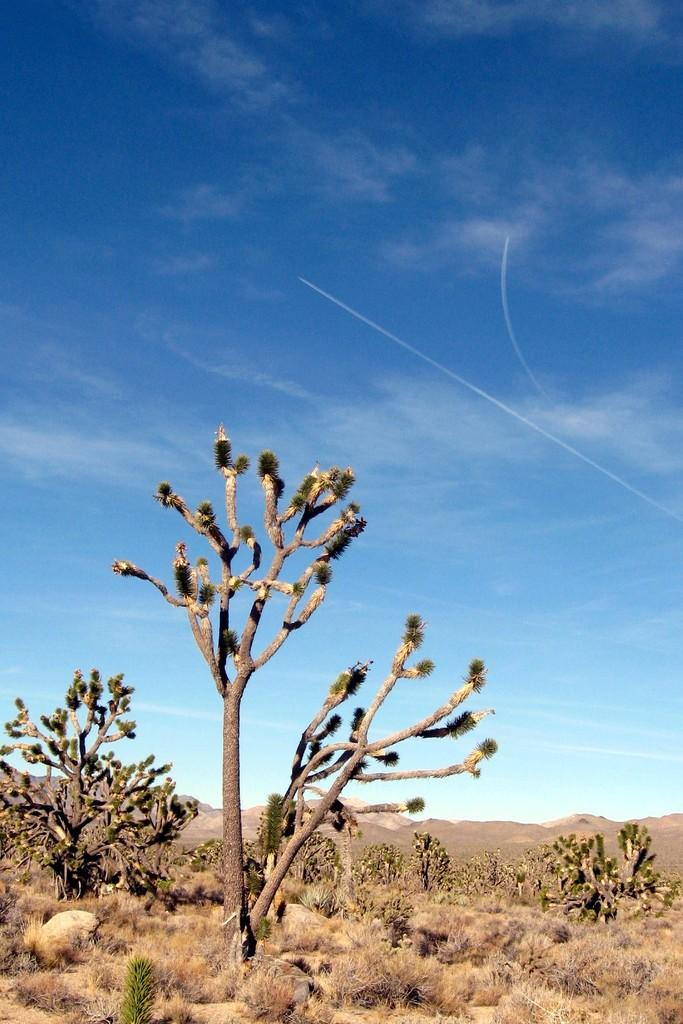What type of vegetation can be seen in the image? There are trees in the image. What is the condition of the ground in the image? There is dry grass in the image. What other objects can be seen on the ground in the image? There are stones in the image. How would you describe the color of the sky in the image? The sky is a combination of white and blue colors. In which direction is the flight taking off in the image? There is no flight present in the image, so it is not possible to determine the direction of a takeoff. 